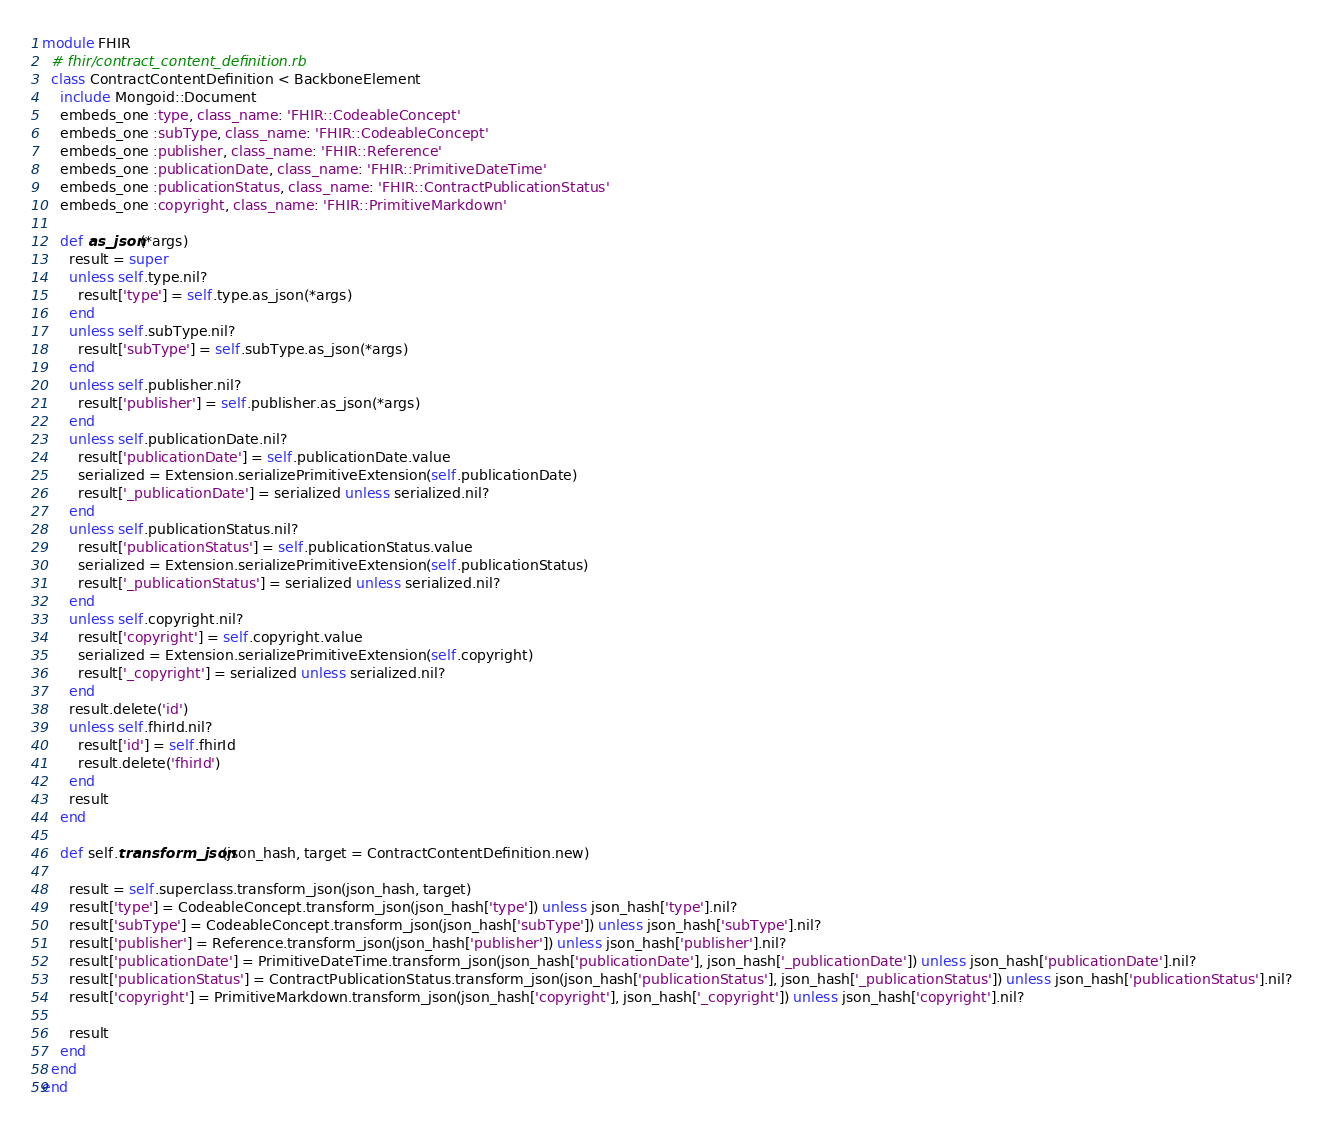<code> <loc_0><loc_0><loc_500><loc_500><_Ruby_>module FHIR
  # fhir/contract_content_definition.rb
  class ContractContentDefinition < BackboneElement
    include Mongoid::Document
    embeds_one :type, class_name: 'FHIR::CodeableConcept'    
    embeds_one :subType, class_name: 'FHIR::CodeableConcept'    
    embeds_one :publisher, class_name: 'FHIR::Reference'    
    embeds_one :publicationDate, class_name: 'FHIR::PrimitiveDateTime'    
    embeds_one :publicationStatus, class_name: 'FHIR::ContractPublicationStatus'    
    embeds_one :copyright, class_name: 'FHIR::PrimitiveMarkdown'    
    
    def as_json(*args)
      result = super      
      unless self.type.nil? 
        result['type'] = self.type.as_json(*args)
      end
      unless self.subType.nil? 
        result['subType'] = self.subType.as_json(*args)
      end
      unless self.publisher.nil? 
        result['publisher'] = self.publisher.as_json(*args)
      end
      unless self.publicationDate.nil? 
        result['publicationDate'] = self.publicationDate.value
        serialized = Extension.serializePrimitiveExtension(self.publicationDate)            
        result['_publicationDate'] = serialized unless serialized.nil?
      end
      unless self.publicationStatus.nil? 
        result['publicationStatus'] = self.publicationStatus.value
        serialized = Extension.serializePrimitiveExtension(self.publicationStatus)            
        result['_publicationStatus'] = serialized unless serialized.nil?
      end
      unless self.copyright.nil? 
        result['copyright'] = self.copyright.value
        serialized = Extension.serializePrimitiveExtension(self.copyright)            
        result['_copyright'] = serialized unless serialized.nil?
      end
      result.delete('id')
      unless self.fhirId.nil?
        result['id'] = self.fhirId
        result.delete('fhirId')
      end  
      result
    end

    def self.transform_json(json_hash, target = ContractContentDefinition.new)
    
      result = self.superclass.transform_json(json_hash, target)
      result['type'] = CodeableConcept.transform_json(json_hash['type']) unless json_hash['type'].nil?
      result['subType'] = CodeableConcept.transform_json(json_hash['subType']) unless json_hash['subType'].nil?
      result['publisher'] = Reference.transform_json(json_hash['publisher']) unless json_hash['publisher'].nil?
      result['publicationDate'] = PrimitiveDateTime.transform_json(json_hash['publicationDate'], json_hash['_publicationDate']) unless json_hash['publicationDate'].nil?
      result['publicationStatus'] = ContractPublicationStatus.transform_json(json_hash['publicationStatus'], json_hash['_publicationStatus']) unless json_hash['publicationStatus'].nil?
      result['copyright'] = PrimitiveMarkdown.transform_json(json_hash['copyright'], json_hash['_copyright']) unless json_hash['copyright'].nil?

      result
    end
  end
end
</code> 